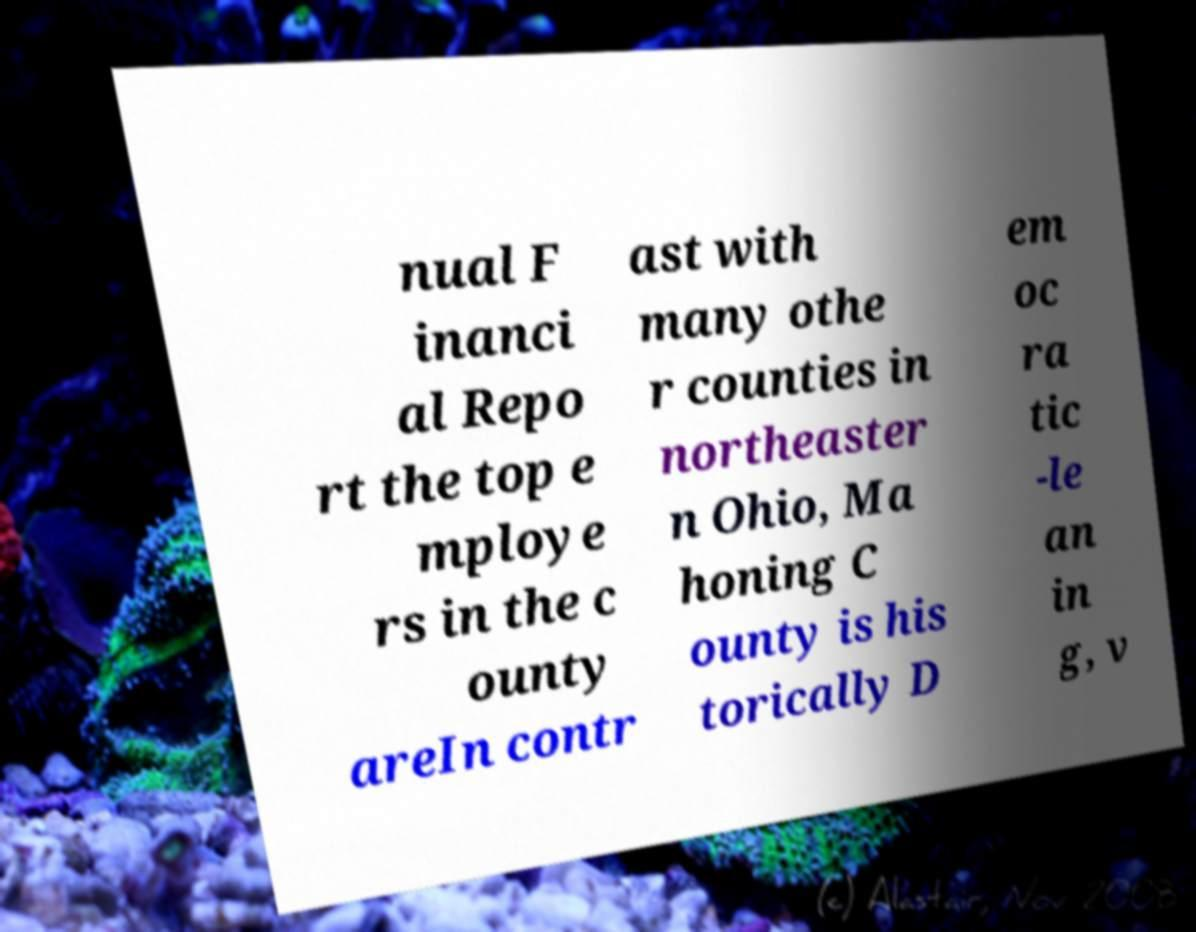Can you read and provide the text displayed in the image?This photo seems to have some interesting text. Can you extract and type it out for me? nual F inanci al Repo rt the top e mploye rs in the c ounty areIn contr ast with many othe r counties in northeaster n Ohio, Ma honing C ounty is his torically D em oc ra tic -le an in g, v 